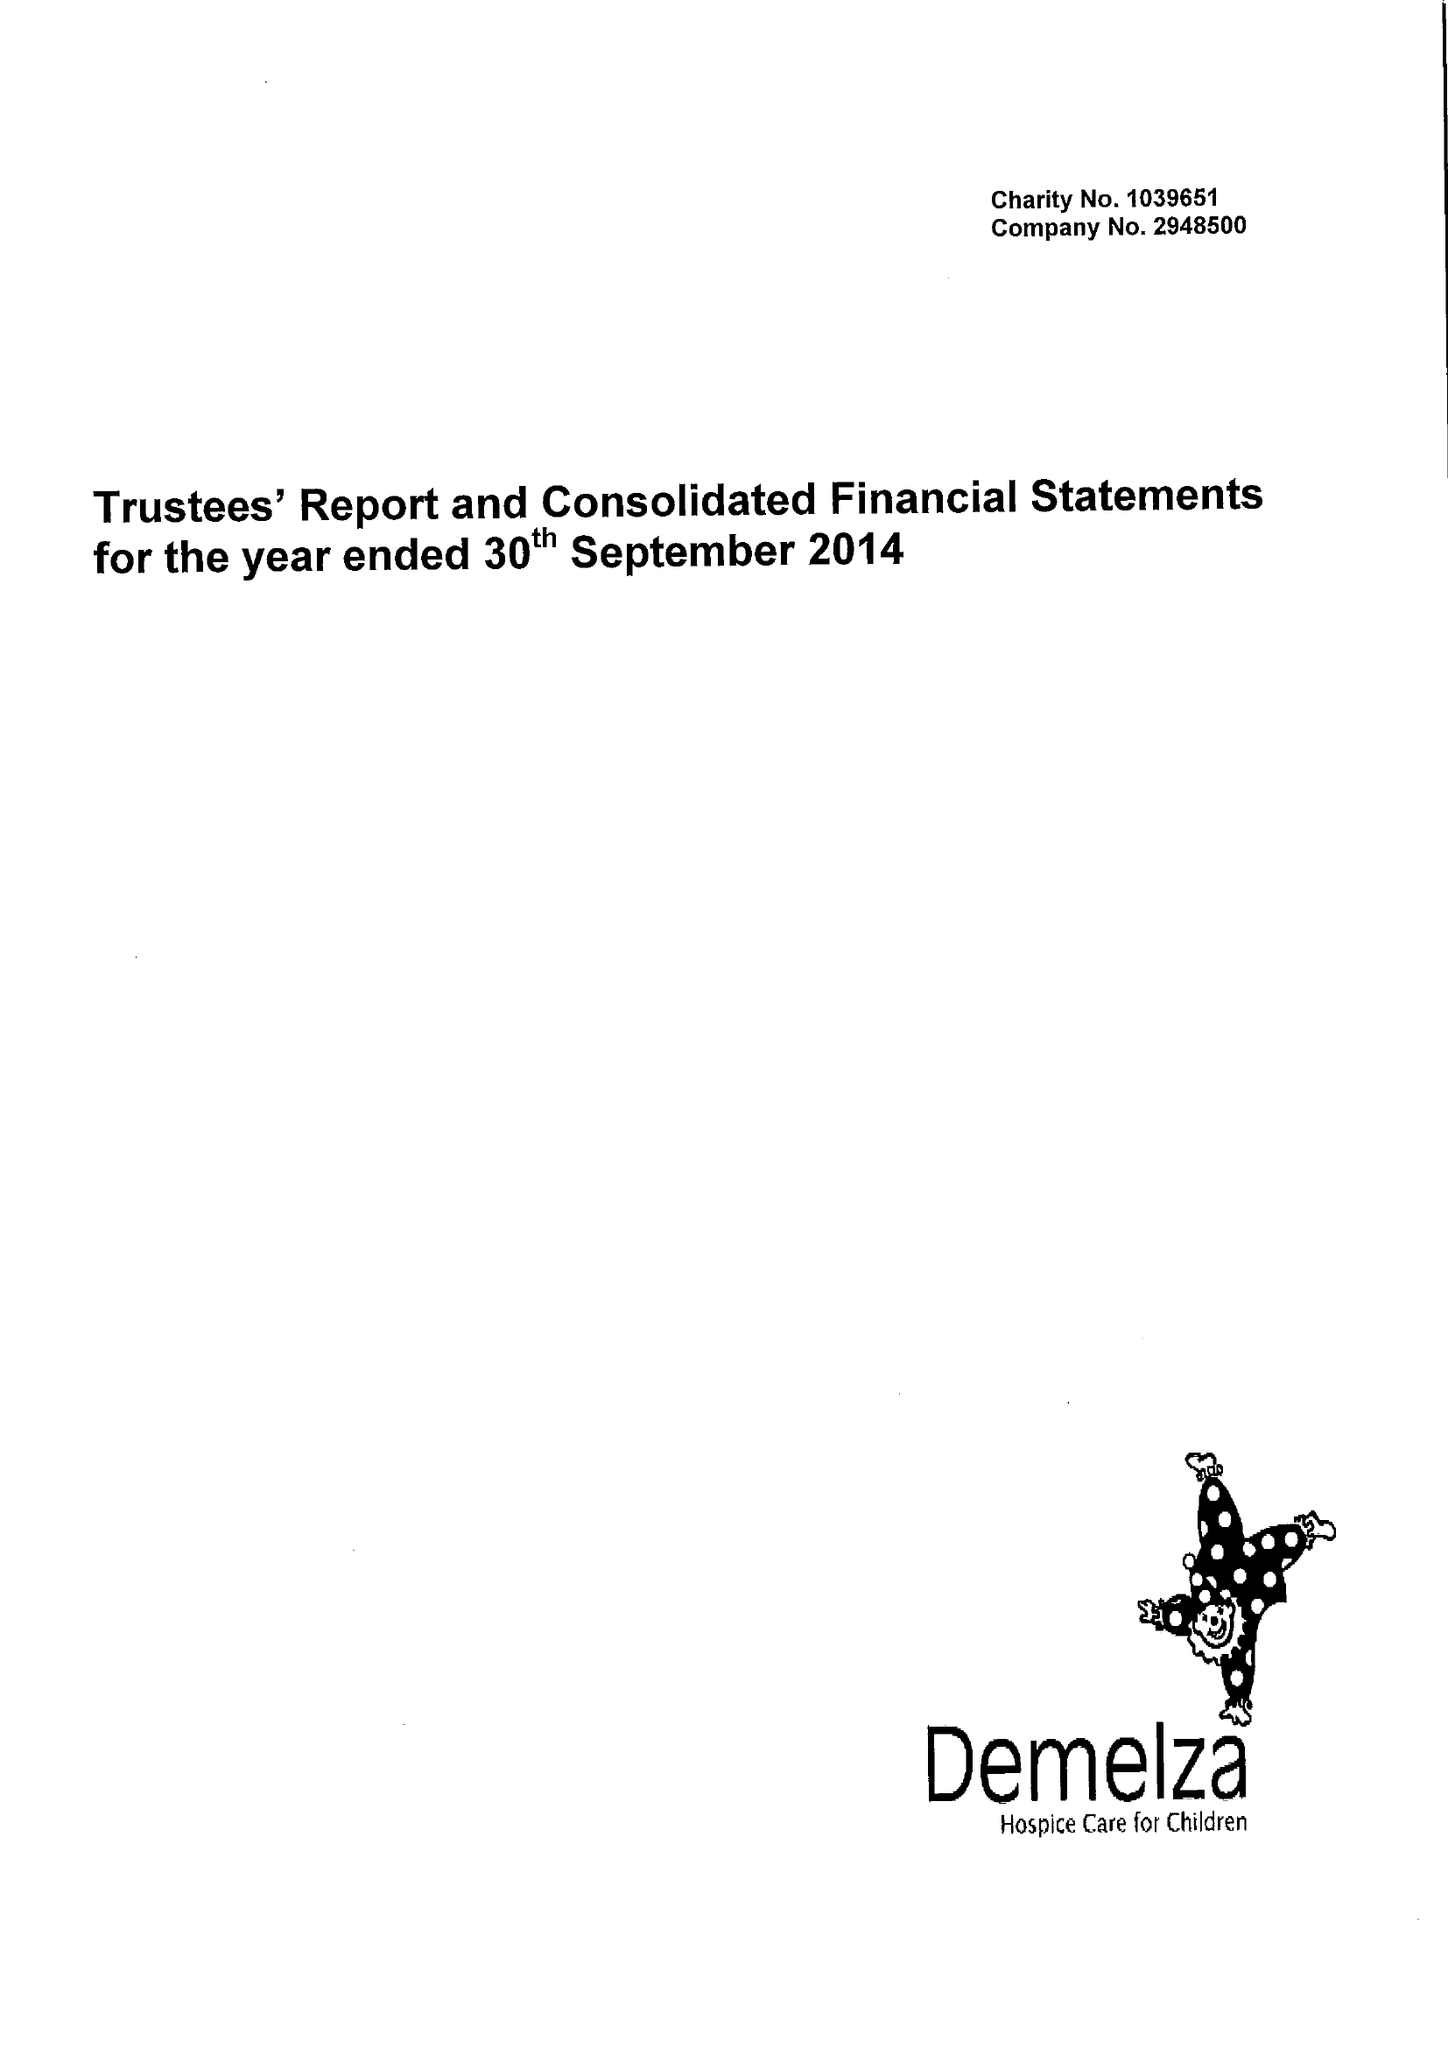What is the value for the charity_number?
Answer the question using a single word or phrase. 1039651 